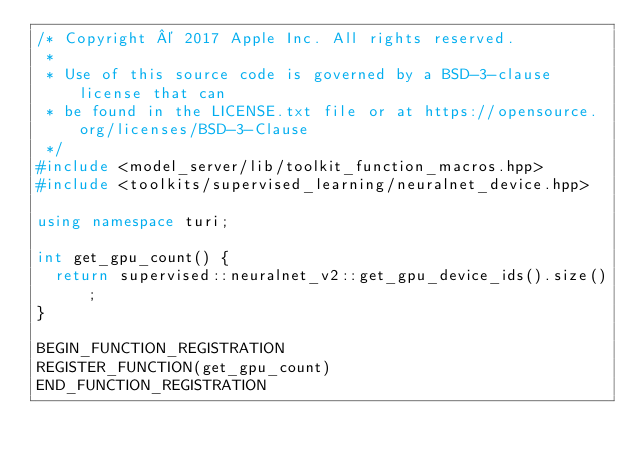<code> <loc_0><loc_0><loc_500><loc_500><_C++_>/* Copyright © 2017 Apple Inc. All rights reserved.
 *
 * Use of this source code is governed by a BSD-3-clause license that can
 * be found in the LICENSE.txt file or at https://opensource.org/licenses/BSD-3-Clause
 */
#include <model_server/lib/toolkit_function_macros.hpp>
#include <toolkits/supervised_learning/neuralnet_device.hpp>

using namespace turi;

int get_gpu_count() {
  return supervised::neuralnet_v2::get_gpu_device_ids().size();
}

BEGIN_FUNCTION_REGISTRATION
REGISTER_FUNCTION(get_gpu_count)
END_FUNCTION_REGISTRATION
</code> 